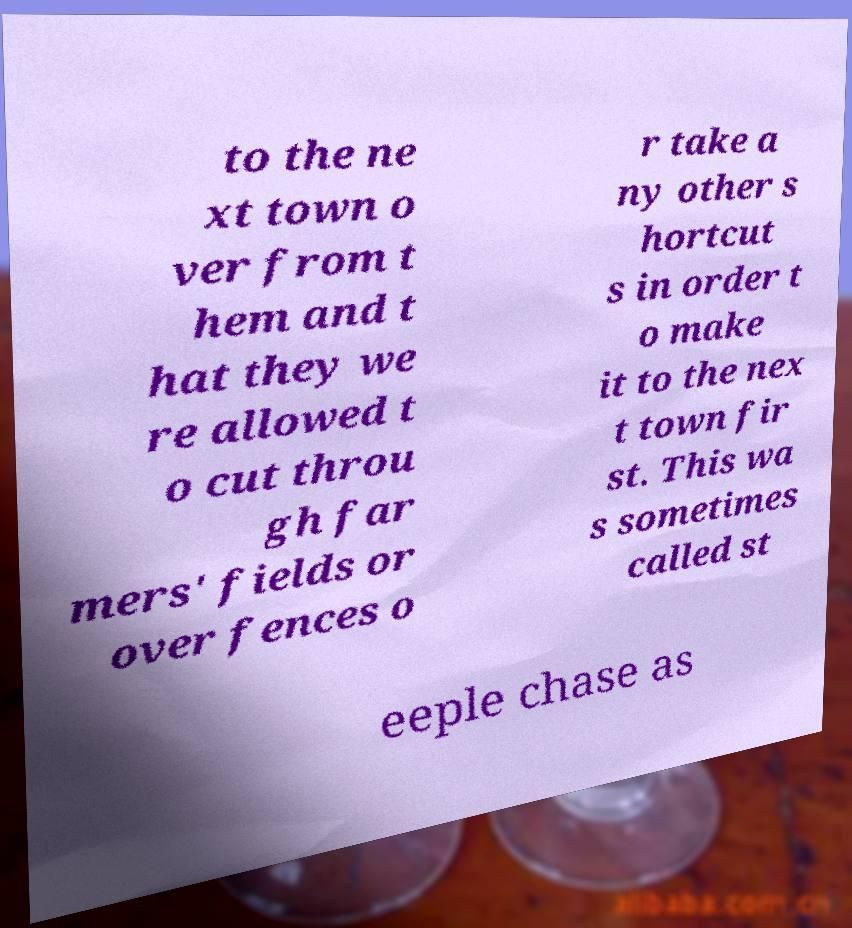Please identify and transcribe the text found in this image. to the ne xt town o ver from t hem and t hat they we re allowed t o cut throu gh far mers' fields or over fences o r take a ny other s hortcut s in order t o make it to the nex t town fir st. This wa s sometimes called st eeple chase as 